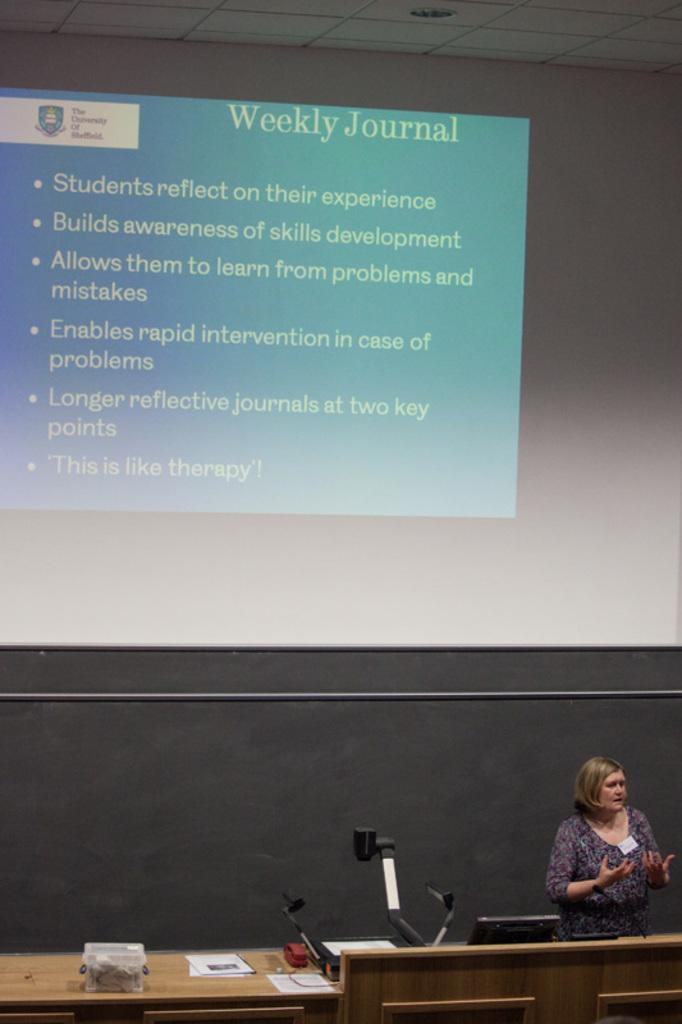What is the person in the image doing? The person is standing and talking. What objects can be seen on the table? Papers, a box, a laptop, and an electrical device are visible on the table. What is in the background of the image? There is a screen and a wall in the background. Can you describe the lighting in the image? There is a light visible at the top of the image. Are there any faucets visible in the image? No, there are no faucets present in the image. How many spiders can be seen crawling on the wall in the background? There are no spiders visible in the image; the wall in the background is clear of any spiders. 